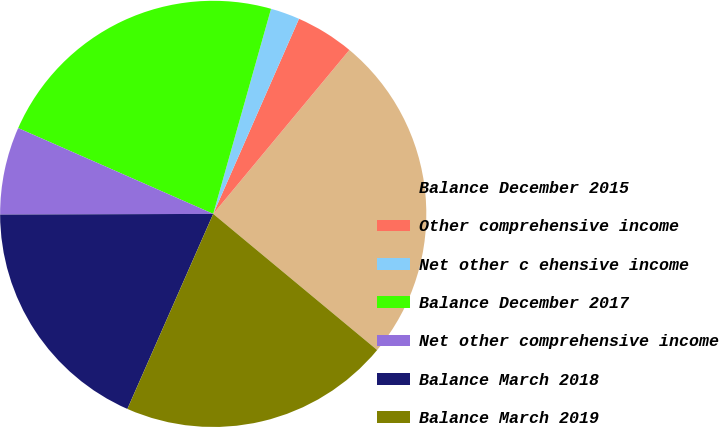<chart> <loc_0><loc_0><loc_500><loc_500><pie_chart><fcel>Balance December 2015<fcel>Other comprehensive income<fcel>Net other c ehensive income<fcel>Balance December 2017<fcel>Net other comprehensive income<fcel>Balance March 2018<fcel>Balance March 2019<nl><fcel>25.0%<fcel>4.44%<fcel>2.22%<fcel>22.78%<fcel>6.65%<fcel>18.35%<fcel>20.57%<nl></chart> 